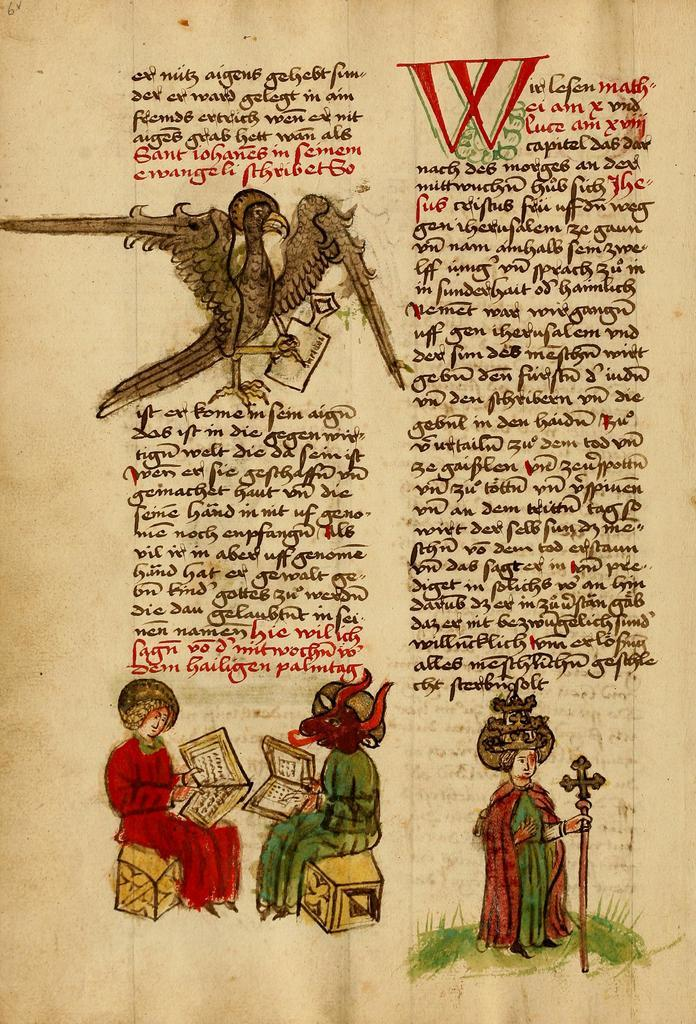What is the main subject of the image? The main subject of the image is a page. What can be found on the page? The page contains text and four images. What type of territory is depicted in the images on the page? There is no territory depicted in the images on the page, as the provided facts only mention the presence of images and text on the page. 